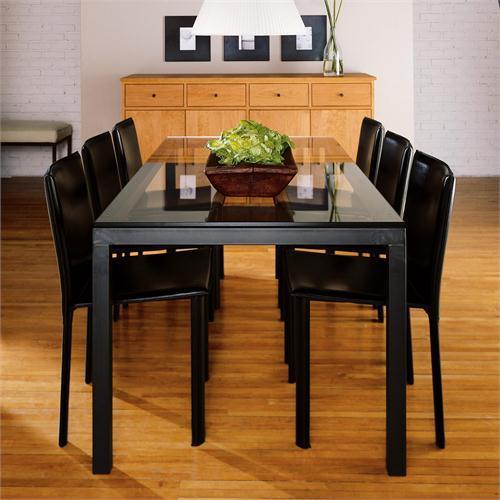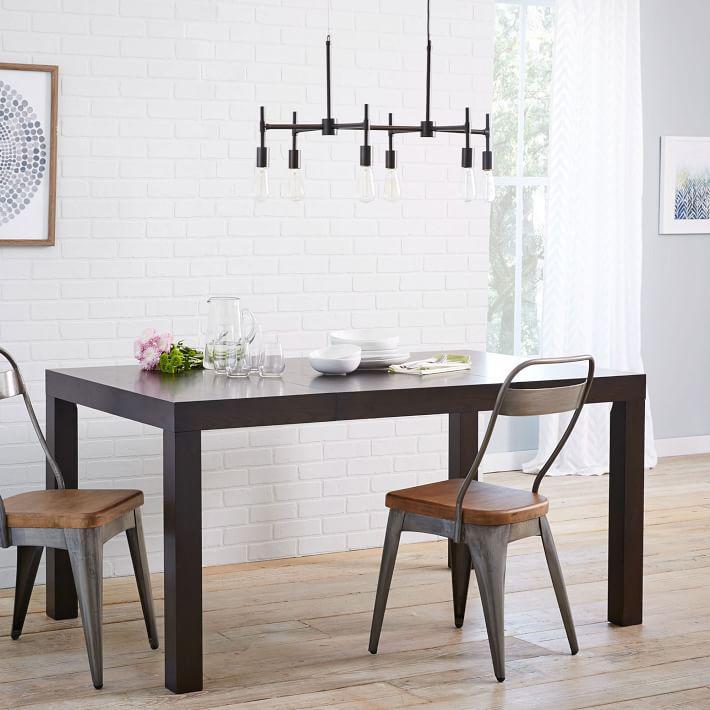The first image is the image on the left, the second image is the image on the right. For the images displayed, is the sentence "there are exactly two chairs in the image on the right" factually correct? Answer yes or no. Yes. 